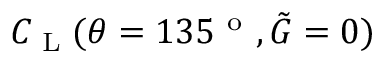<formula> <loc_0><loc_0><loc_500><loc_500>C _ { L } ( \theta = 1 3 5 ^ { o } , \tilde { G } = 0 )</formula> 